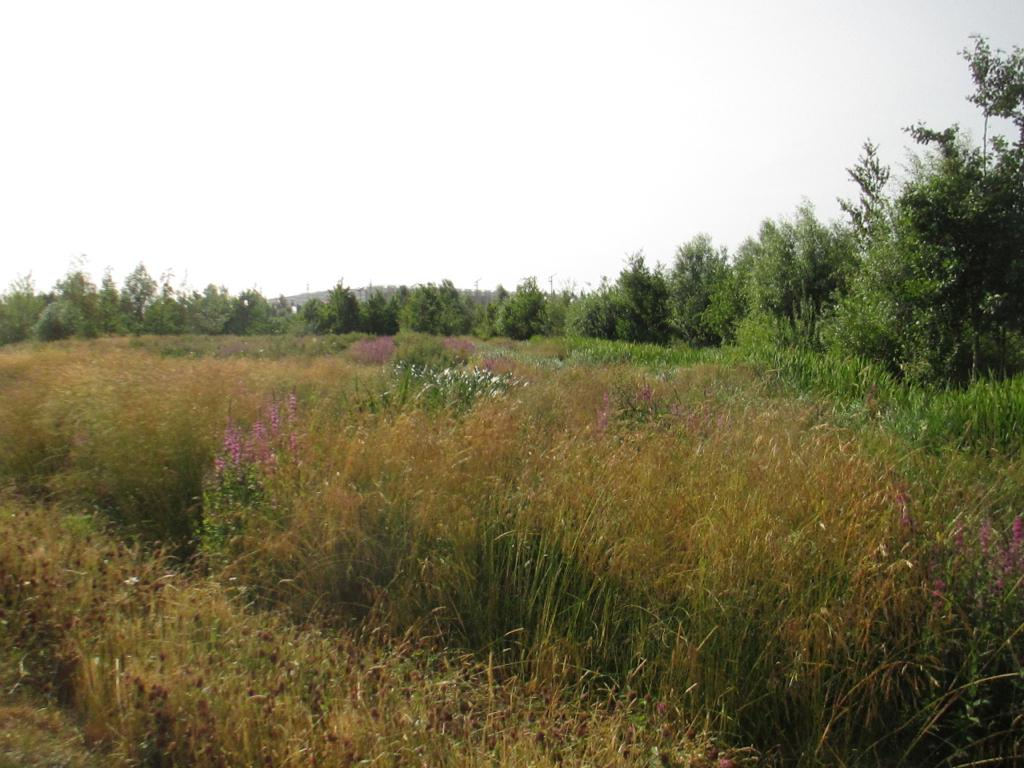What type of vegetation is in the foreground of the image? There is grass and flowers in the foreground of the image. What else can be seen in the foreground besides the vegetation? There are no other objects or subjects in the foreground besides the grass and flowers. What type of vegetation is in the background of the image? There are trees in the background of the image. What is visible at the top of the image? The sky is visible at the top of the image. What type of knife is being used in the protest depicted in the image? There is no protest or knife present in the image; it features grass, flowers, trees, and the sky. What type of insect can be seen crawling on the flowers in the image? There are no insects visible in the image; it only features grass, flowers, trees, and the sky. 